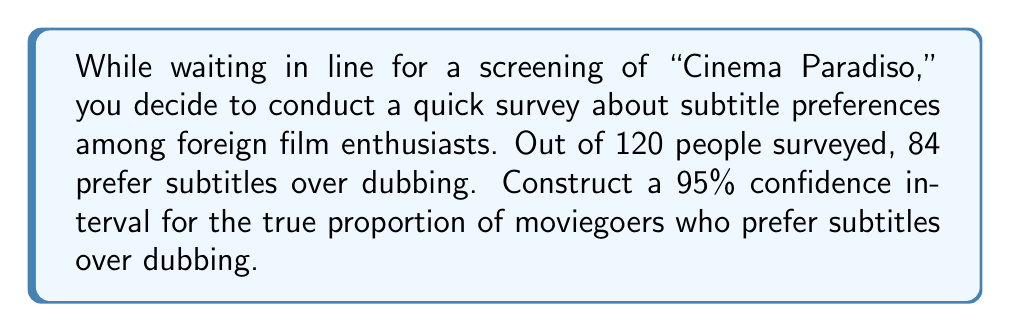What is the answer to this math problem? Let's approach this step-by-step:

1) We're dealing with a proportion, so we'll use the formula for a confidence interval for a proportion:

   $$\hat{p} \pm z^* \sqrt{\frac{\hat{p}(1-\hat{p})}{n}}$$

   Where:
   $\hat{p}$ = sample proportion
   $z^*$ = critical value for the desired confidence level
   $n$ = sample size

2) Calculate $\hat{p}$:
   $\hat{p} = \frac{84}{120} = 0.7$

3) For a 95% confidence interval, $z^* = 1.96$

4) Now, let's substitute these values into our formula:

   $$0.7 \pm 1.96 \sqrt{\frac{0.7(1-0.7)}{120}}$$

5) Simplify under the square root:
   $$0.7 \pm 1.96 \sqrt{\frac{0.7(0.3)}{120}} = 0.7 \pm 1.96 \sqrt{\frac{0.21}{120}}$$

6) Calculate:
   $$0.7 \pm 1.96 \sqrt{0.00175} = 0.7 \pm 1.96(0.0418)$$
   $$0.7 \pm 0.0820$$

7) Therefore, the confidence interval is:
   $$(0.7 - 0.0820, 0.7 + 0.0820) = (0.618, 0.782)$$
Answer: (0.618, 0.782) 